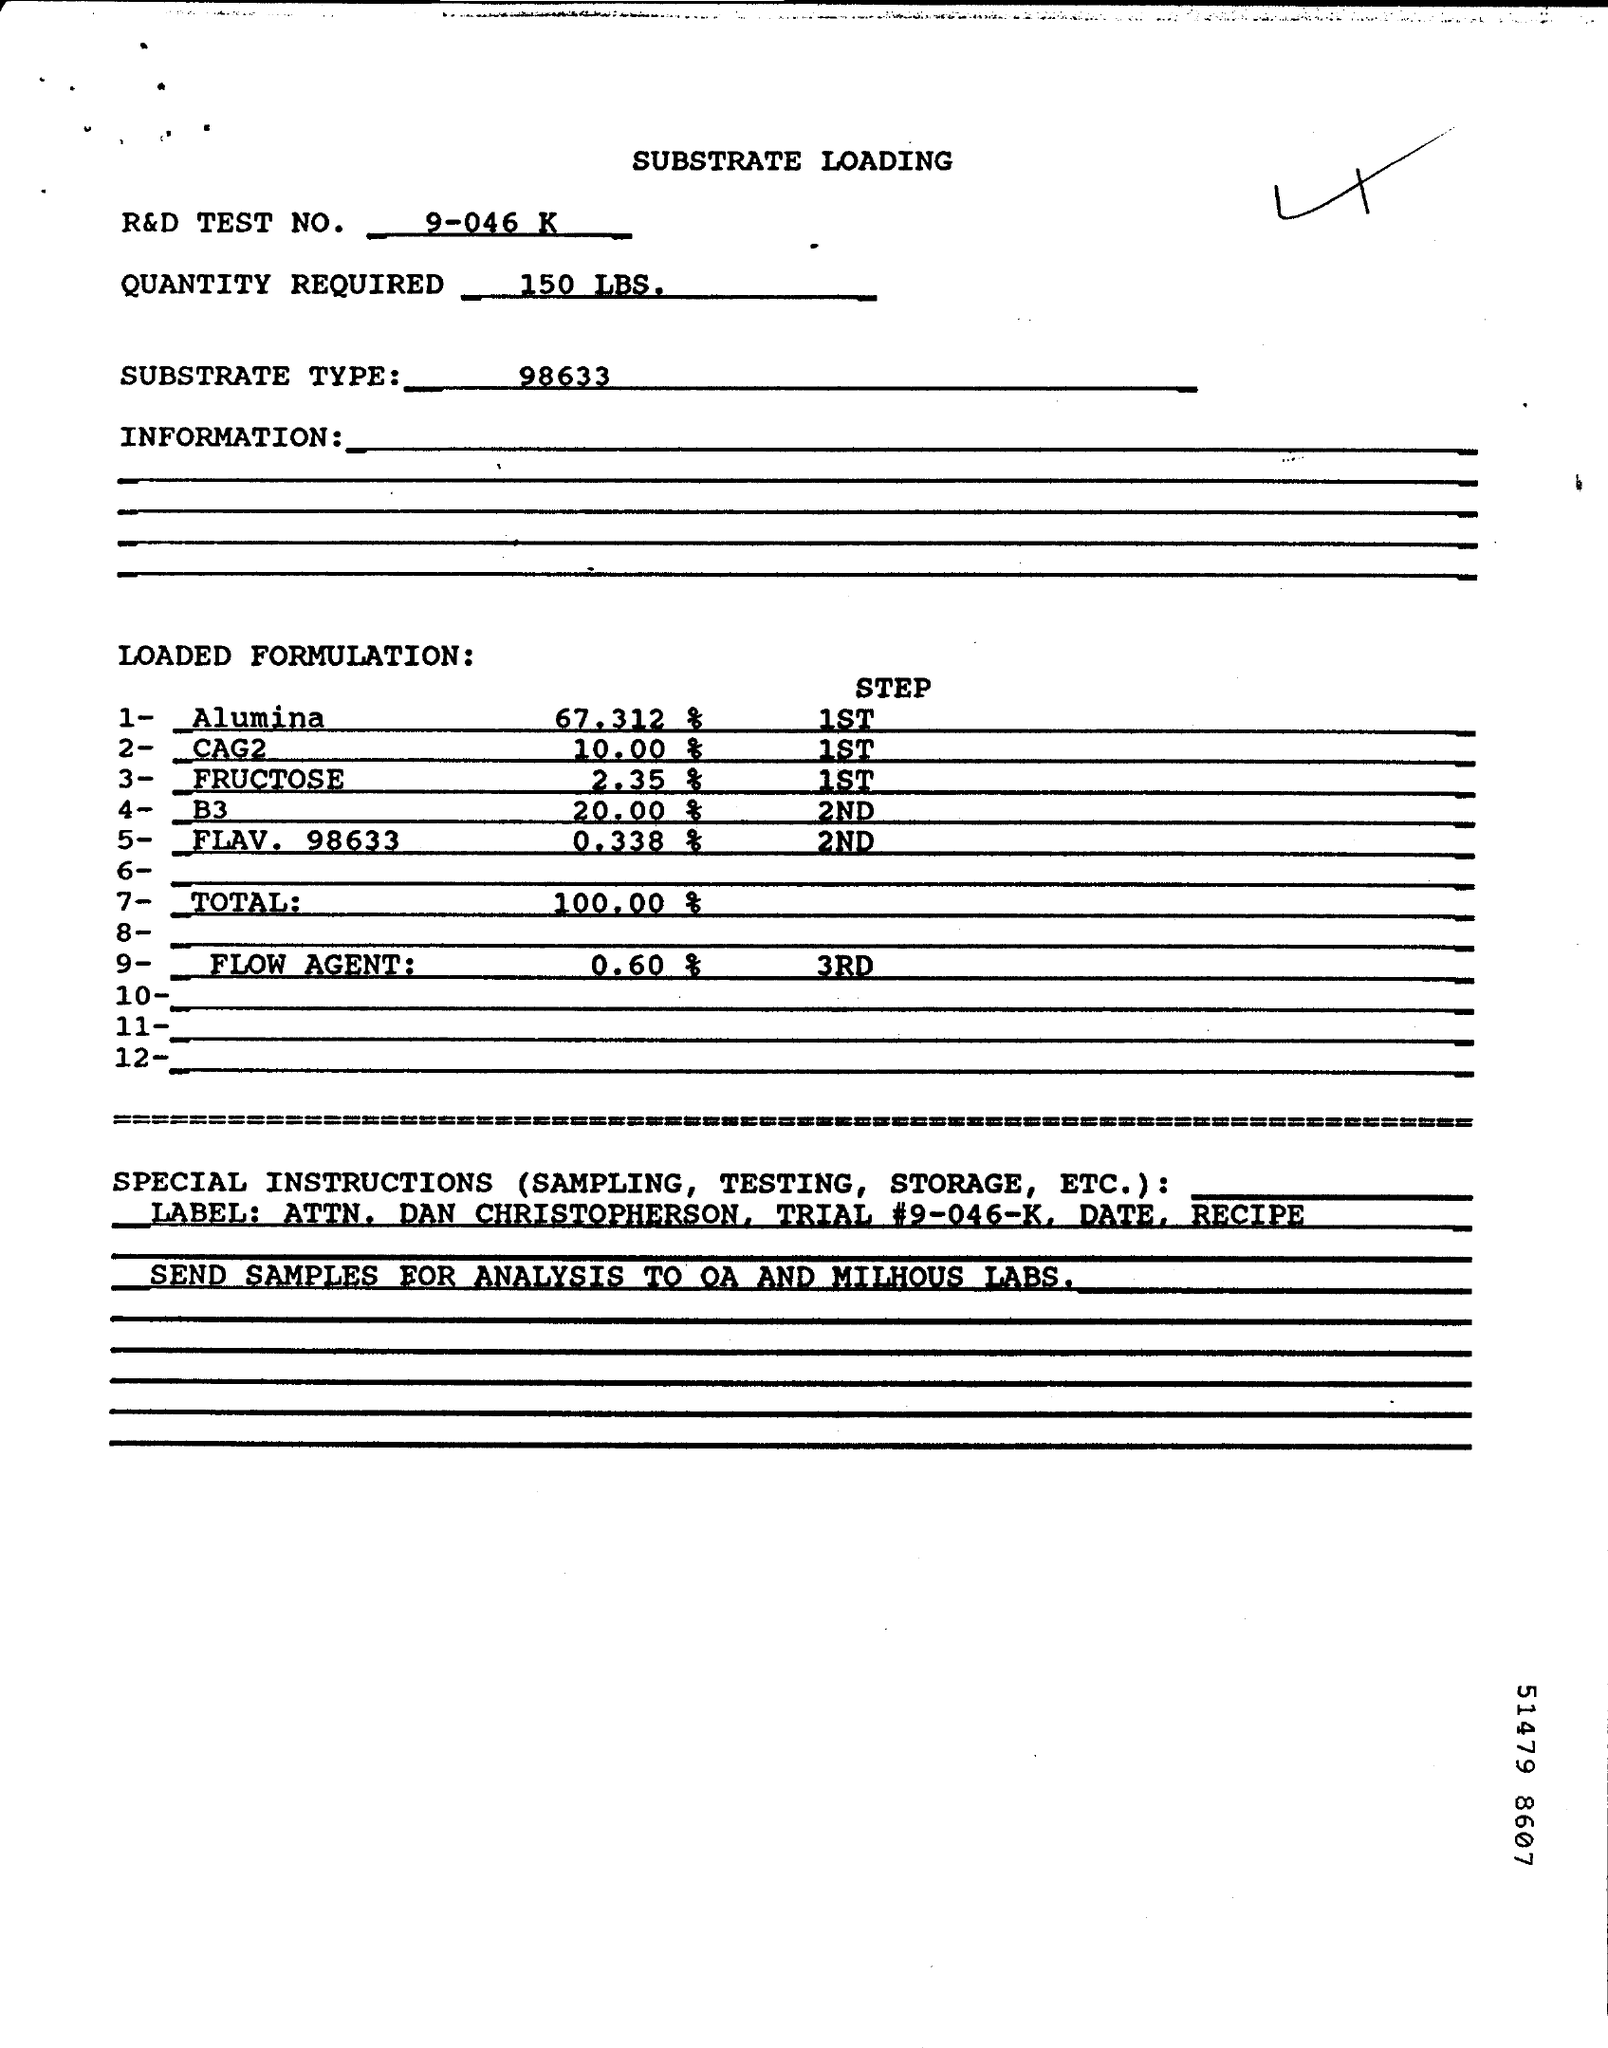What is the R&D Test No. given in the document?
Make the answer very short. 9-046 K. How much quantity is required as per the document?
Your response must be concise. 150 LBS. What is the Substrate Type mentioned in the document?
Ensure brevity in your answer.  98633. 